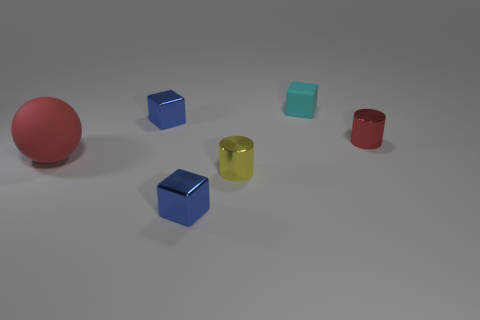Subtract all small cyan cubes. How many cubes are left? 2 Subtract all purple cylinders. How many blue cubes are left? 2 Subtract all cyan blocks. How many blocks are left? 2 Add 3 red rubber things. How many objects exist? 9 Subtract all red blocks. Subtract all gray cylinders. How many blocks are left? 3 Subtract all green balls. Subtract all tiny red metallic objects. How many objects are left? 5 Add 2 red rubber things. How many red rubber things are left? 3 Add 5 big objects. How many big objects exist? 6 Subtract 0 brown cylinders. How many objects are left? 6 Subtract all cylinders. How many objects are left? 4 